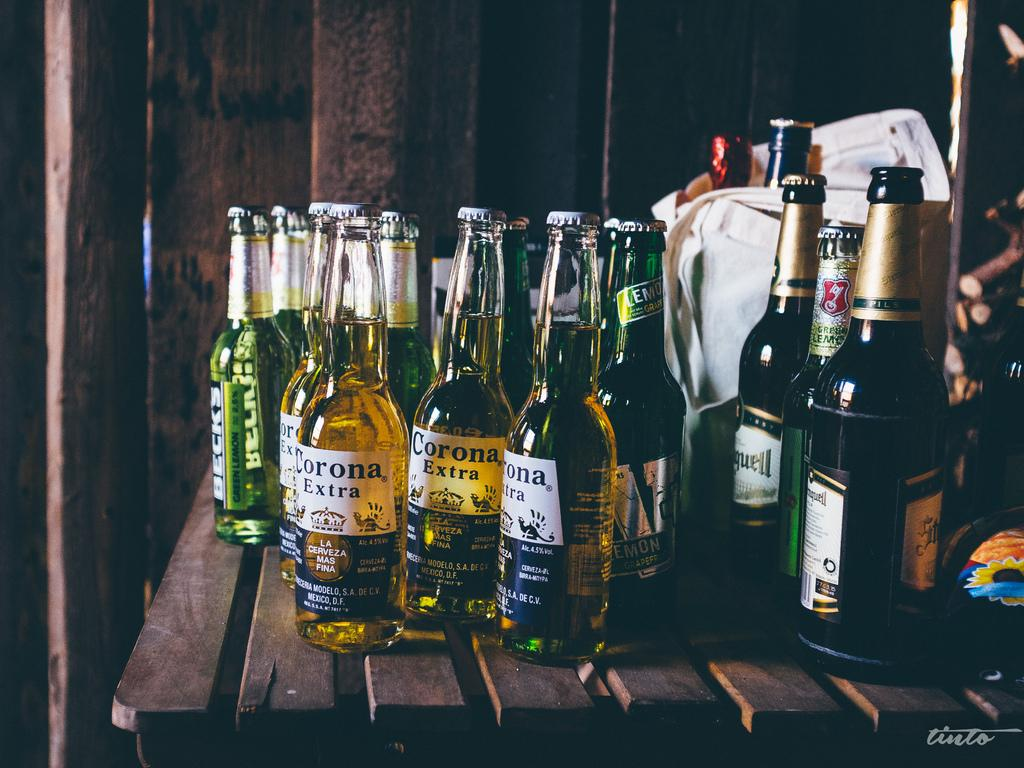<image>
Relay a brief, clear account of the picture shown. several bottles of Corona Extra beer on a wooden table 